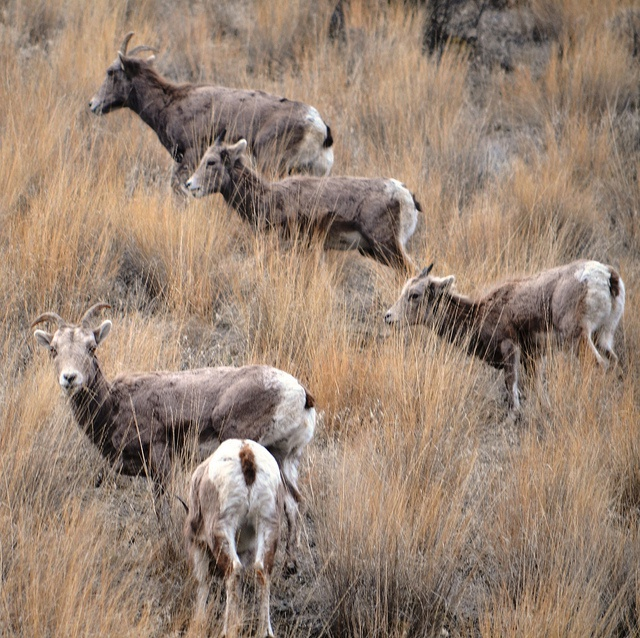Describe the objects in this image and their specific colors. I can see sheep in gray, darkgray, black, and lightgray tones, sheep in gray, darkgray, and black tones, sheep in gray, darkgray, and black tones, sheep in gray, darkgray, and lightgray tones, and sheep in gray, darkgray, and black tones in this image. 